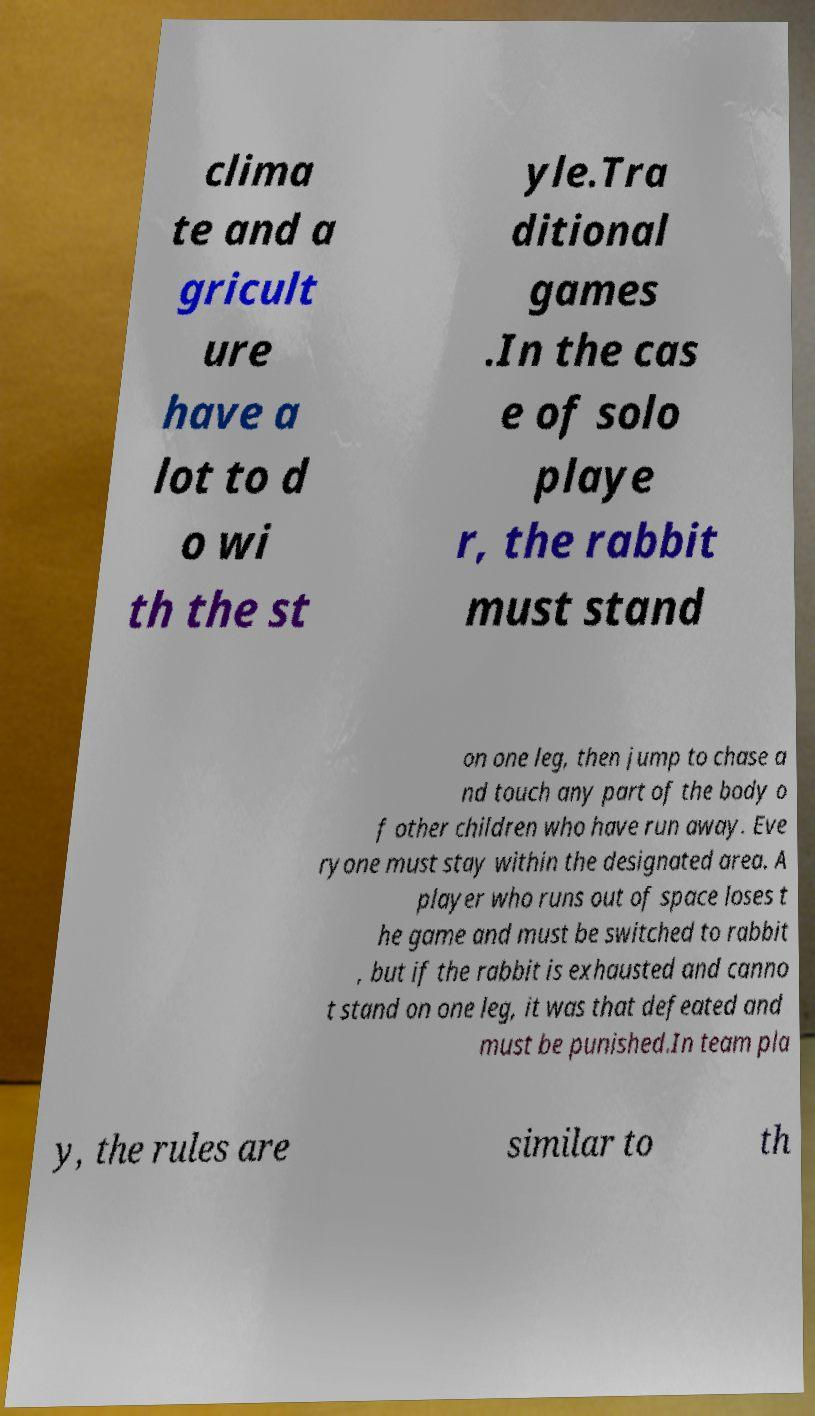What messages or text are displayed in this image? I need them in a readable, typed format. clima te and a gricult ure have a lot to d o wi th the st yle.Tra ditional games .In the cas e of solo playe r, the rabbit must stand on one leg, then jump to chase a nd touch any part of the body o f other children who have run away. Eve ryone must stay within the designated area. A player who runs out of space loses t he game and must be switched to rabbit , but if the rabbit is exhausted and canno t stand on one leg, it was that defeated and must be punished.In team pla y, the rules are similar to th 